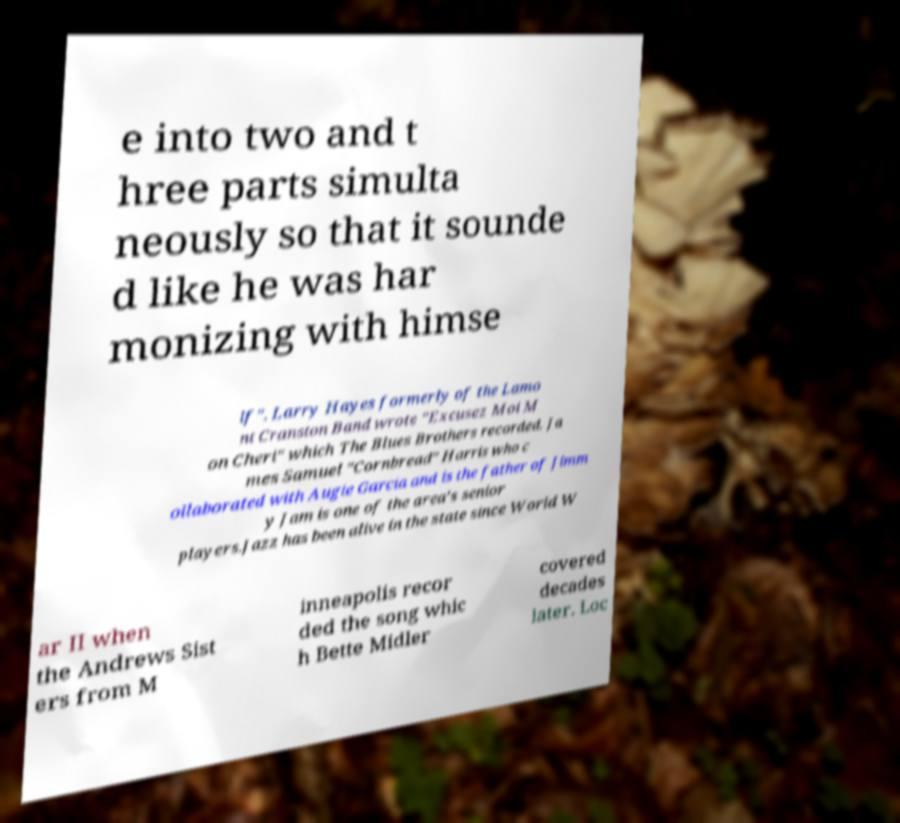Please read and relay the text visible in this image. What does it say? e into two and t hree parts simulta neously so that it sounde d like he was har monizing with himse lf". Larry Hayes formerly of the Lamo nt Cranston Band wrote "Excusez Moi M on Cheri" which The Blues Brothers recorded. Ja mes Samuel "Cornbread" Harris who c ollaborated with Augie Garcia and is the father of Jimm y Jam is one of the area's senior players.Jazz has been alive in the state since World W ar II when the Andrews Sist ers from M inneapolis recor ded the song whic h Bette Midler covered decades later. Loc 